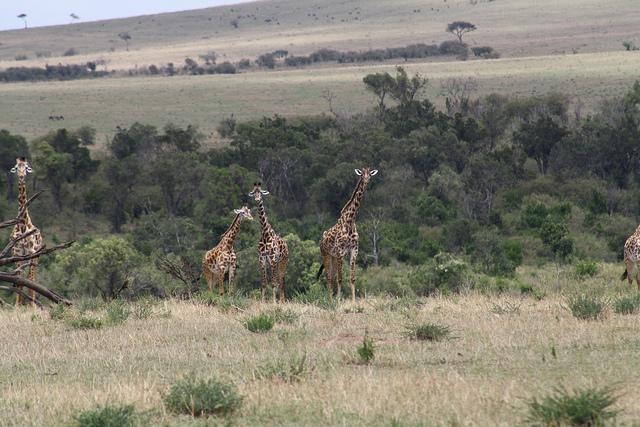How many animals are shown?
Give a very brief answer. 5. How many giraffes are there?
Give a very brief answer. 5. 